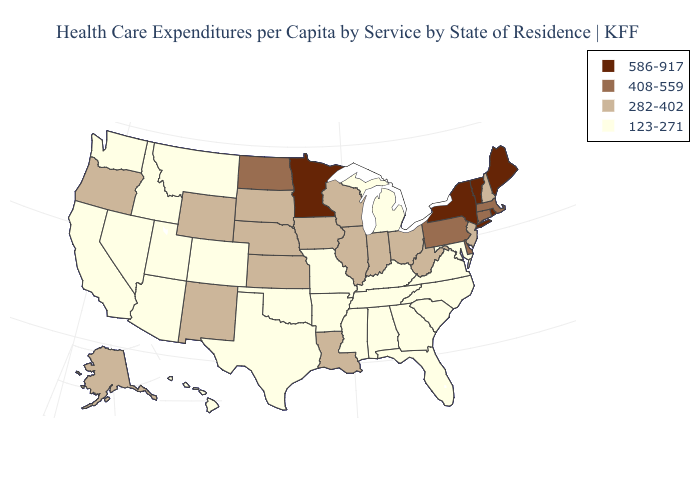Does Ohio have the highest value in the USA?
Keep it brief. No. Name the states that have a value in the range 586-917?
Write a very short answer. Maine, Minnesota, New York, Rhode Island, Vermont. Among the states that border West Virginia , does Virginia have the highest value?
Concise answer only. No. What is the lowest value in the Northeast?
Give a very brief answer. 282-402. Does the first symbol in the legend represent the smallest category?
Answer briefly. No. Name the states that have a value in the range 282-402?
Write a very short answer. Alaska, Illinois, Indiana, Iowa, Kansas, Louisiana, Nebraska, New Hampshire, New Jersey, New Mexico, Ohio, Oregon, South Dakota, West Virginia, Wisconsin, Wyoming. Name the states that have a value in the range 408-559?
Short answer required. Connecticut, Delaware, Massachusetts, North Dakota, Pennsylvania. What is the lowest value in the Northeast?
Answer briefly. 282-402. Among the states that border Nevada , does Oregon have the lowest value?
Quick response, please. No. Name the states that have a value in the range 282-402?
Concise answer only. Alaska, Illinois, Indiana, Iowa, Kansas, Louisiana, Nebraska, New Hampshire, New Jersey, New Mexico, Ohio, Oregon, South Dakota, West Virginia, Wisconsin, Wyoming. Does Vermont have the highest value in the Northeast?
Short answer required. Yes. What is the value of Nevada?
Be succinct. 123-271. Does New Hampshire have the highest value in the Northeast?
Concise answer only. No. Name the states that have a value in the range 586-917?
Quick response, please. Maine, Minnesota, New York, Rhode Island, Vermont. 